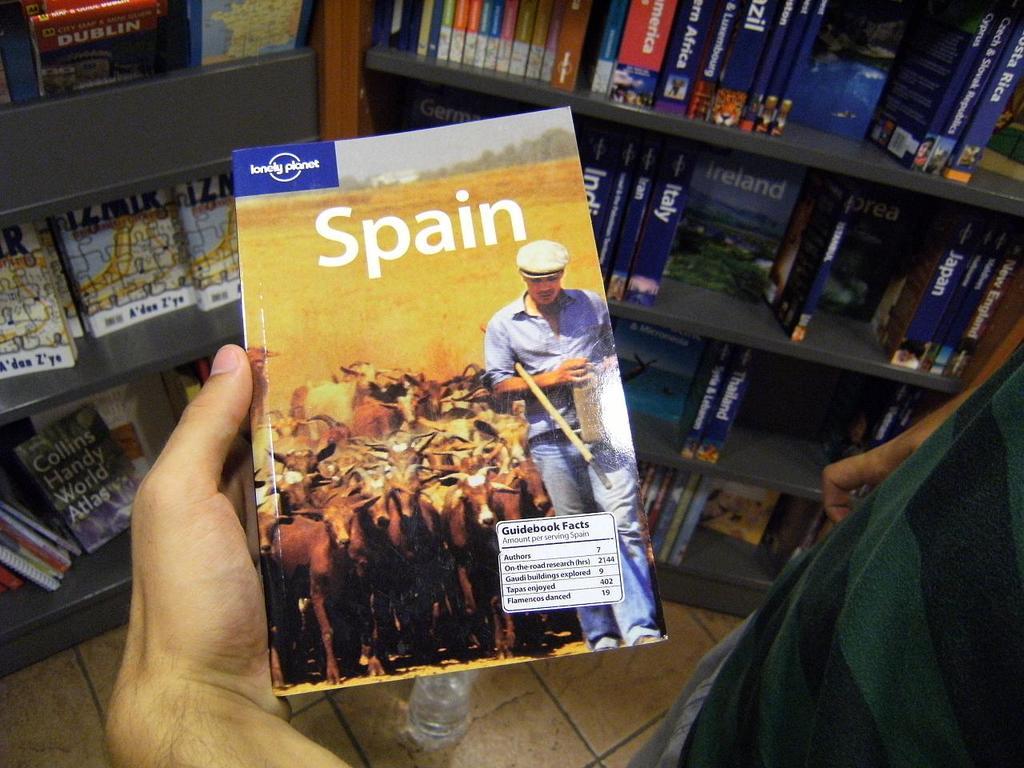Which country is the travel guide about?
Offer a very short reply. Spain. Who is the publisher of the book?
Your answer should be compact. Lonely planet. 